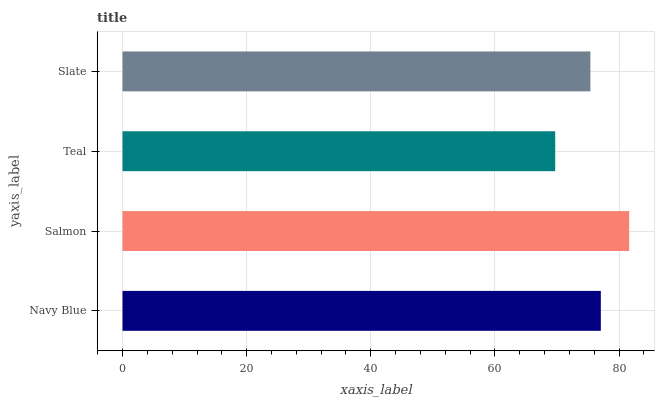Is Teal the minimum?
Answer yes or no. Yes. Is Salmon the maximum?
Answer yes or no. Yes. Is Salmon the minimum?
Answer yes or no. No. Is Teal the maximum?
Answer yes or no. No. Is Salmon greater than Teal?
Answer yes or no. Yes. Is Teal less than Salmon?
Answer yes or no. Yes. Is Teal greater than Salmon?
Answer yes or no. No. Is Salmon less than Teal?
Answer yes or no. No. Is Navy Blue the high median?
Answer yes or no. Yes. Is Slate the low median?
Answer yes or no. Yes. Is Slate the high median?
Answer yes or no. No. Is Teal the low median?
Answer yes or no. No. 